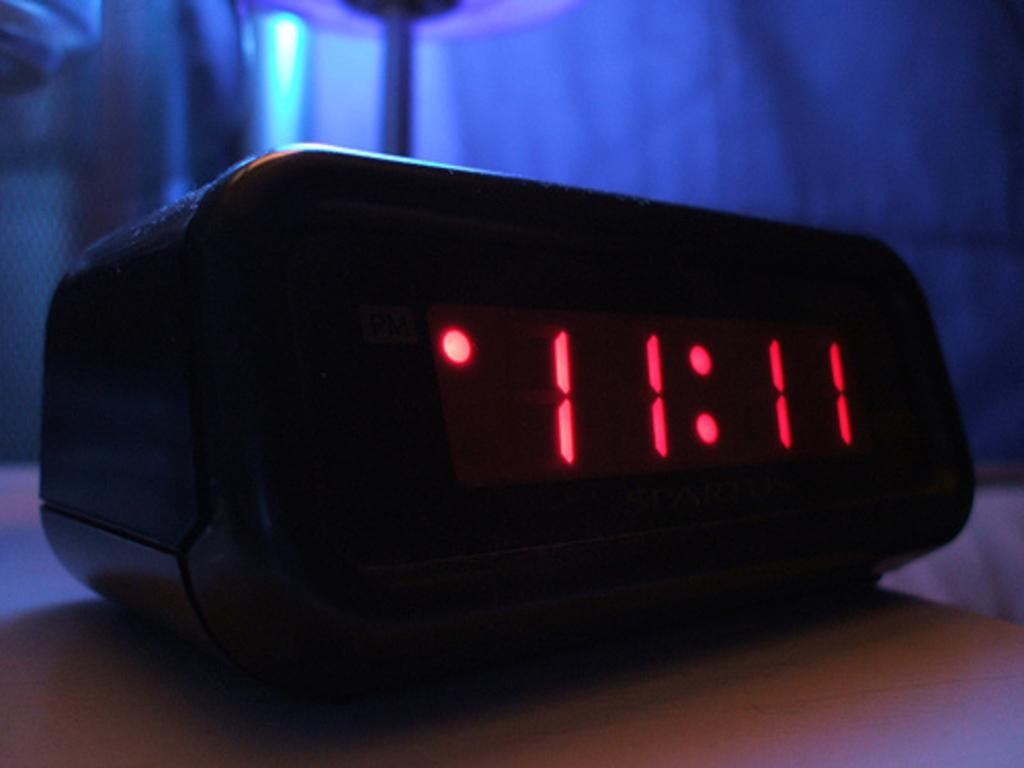<image>
Give a short and clear explanation of the subsequent image. A clock reads 11:11 sits in a dark room. 